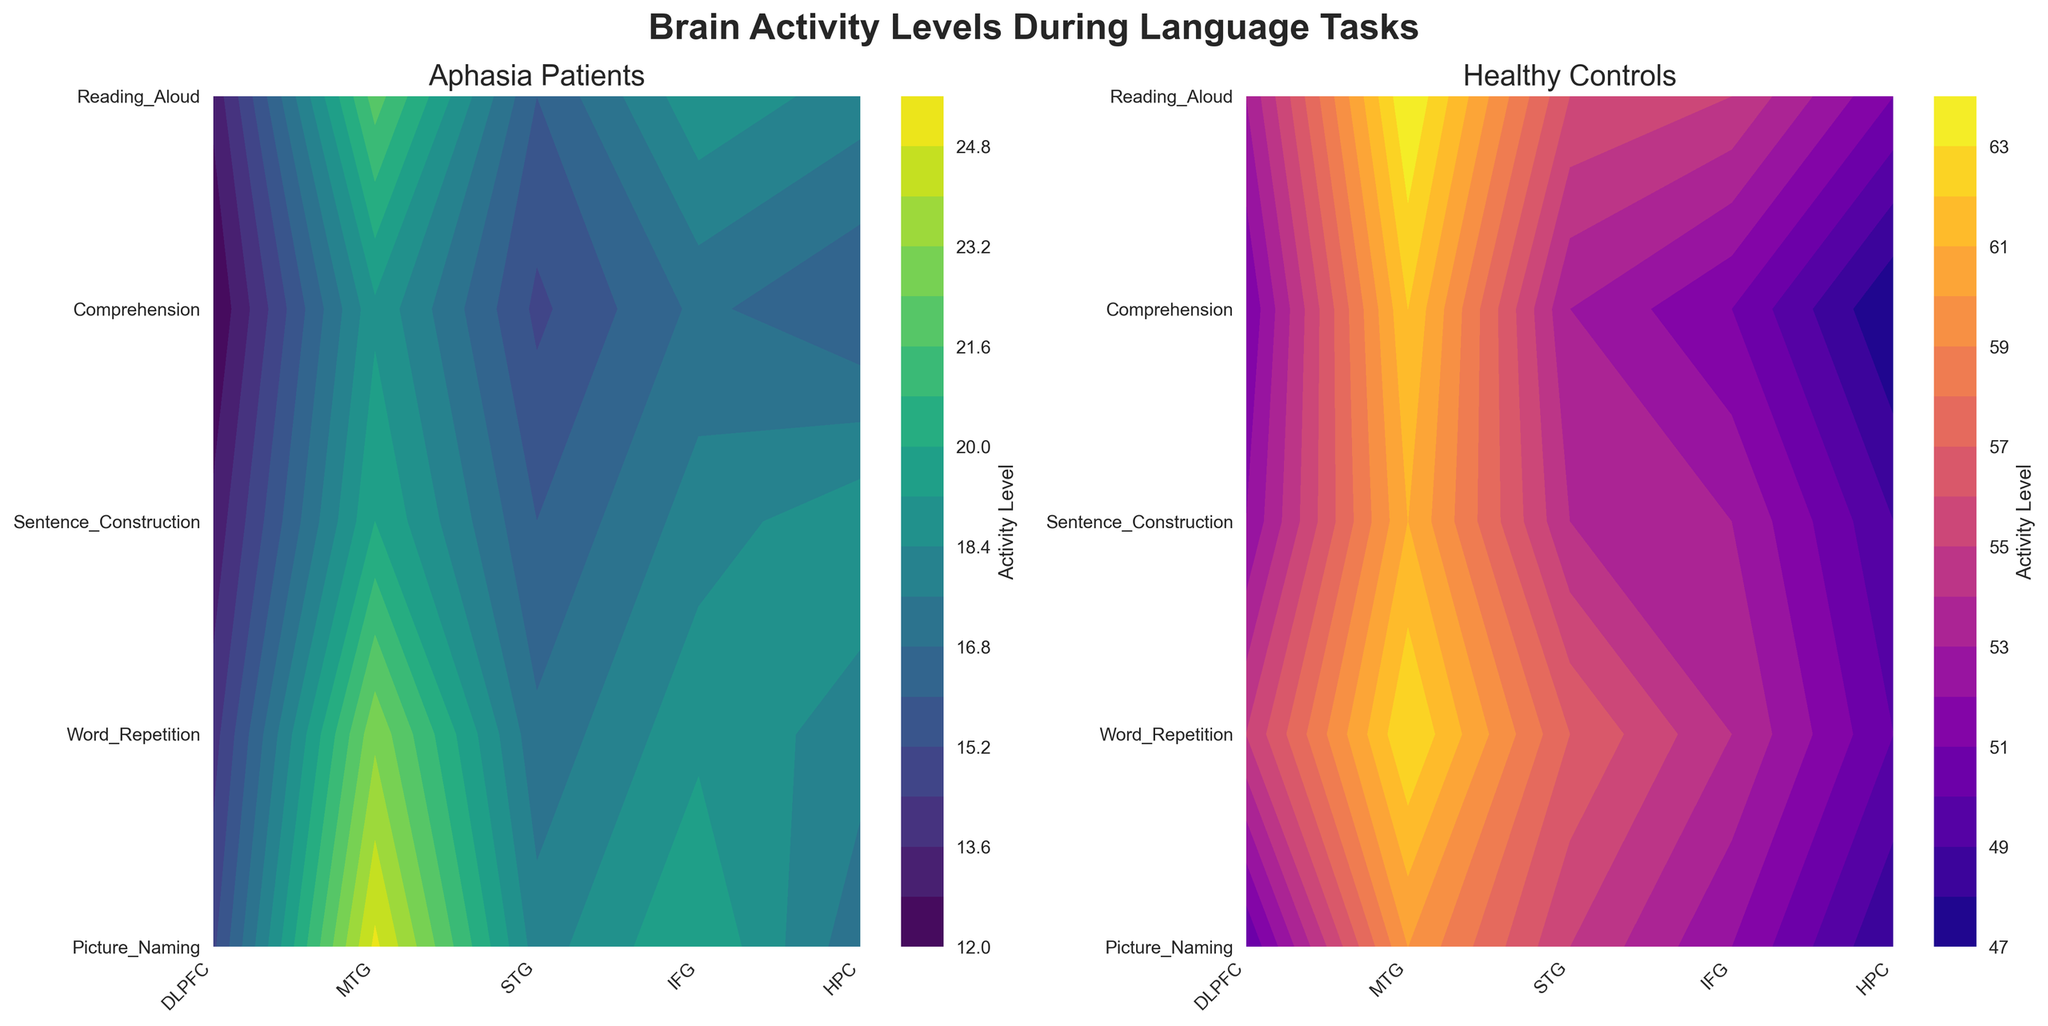Which patient type has higher overall brain activity levels during language tasks? Look at the color intensity in both plots. The plot for Healthy Controls is brighter (higher activity levels) compared to the Aphasia Patients.
Answer: Healthy Controls What are the titles of the subplots? The titles of the subplots are found above each plot. The left one says "Aphasia Patients" and the right one says "Healthy Controls".
Answer: Aphasia Patients, Healthy Controls During which task does the DLPFC show the highest activity level in healthy controls? On the right subplot titled "Healthy Controls", trace the activity levels along the DLPFC column (first column) and identify the task row (y-axis) with the highest value.
Answer: Word_Repetition Which brain region has the highest activity level difference between aphasia patients and healthy controls during Picture Naming? Compare the values for aphasia patients and healthy controls in the "Picture_Naming" row for each brain region. The largest difference is between DLPFC (15 vs 50).
Answer: DLPFC How does the activity in the STG during Sentence Construction compare between the two patient types? Look at the STG column (third column) and the Sentence_Construction row (third row) for both plots. Healthy Controls show higher activity (54 vs 16).
Answer: Healthy Controls have higher activity What is the color bar label in the plots? The color bar label is located next to the color bar itself. It shows what the contour levels represent.
Answer: Activity Level Is the comprehension task more active in the DLPFC region for healthy controls or aphasia patients? Compare the activity levels in the DLPFC column (first column) and Comprehension row (fourth row) for both plots. Healthy controls show higher activity (51 vs 12).
Answer: Healthy Controls Which brain region shows the least activity in aphasia patients during the Reading Aloud task? Check the activity levels in the Reading_Aloud row (fifth row) for aphasia patients and identify the lowest value.
Answer: DLPFC Is there any brain region where aphasia patients have higher activity levels than healthy controls in any task? By comparing the values for each brain region across all tasks in both plots, it is seen that aphasia patients have lower activity levels across all brain regions and tasks.
Answer: No 